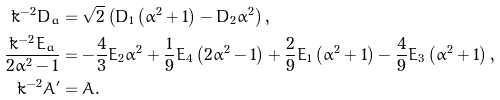Convert formula to latex. <formula><loc_0><loc_0><loc_500><loc_500>\tilde { k } ^ { - 2 } D _ { a } & = \sqrt { 2 } \left ( D _ { 1 } \left ( \alpha ^ { 2 } + 1 \right ) - D _ { 2 } \alpha ^ { 2 } \right ) , \\ \frac { \tilde { k } ^ { - 2 } E _ { a } } { 2 \alpha ^ { 2 } - 1 } & = - \frac { 4 } { 3 } E _ { 2 } \alpha ^ { 2 } + \frac { 1 } { 9 } E _ { 4 } \left ( 2 \alpha ^ { 2 } - 1 \right ) + \frac { 2 } { 9 } E _ { 1 } \left ( \alpha ^ { 2 } + 1 \right ) - \frac { 4 } { 9 } E _ { 3 } \left ( \alpha ^ { 2 } + 1 \right ) , \\ \tilde { k } ^ { - 2 } A ^ { \prime } & = A .</formula> 